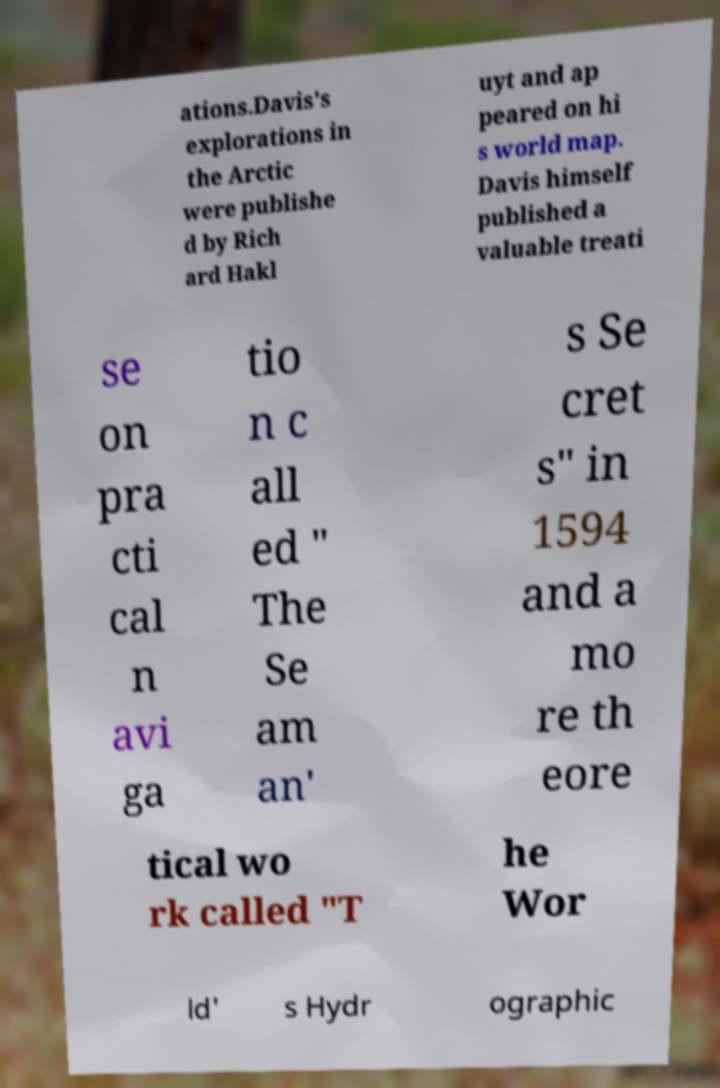For documentation purposes, I need the text within this image transcribed. Could you provide that? ations.Davis's explorations in the Arctic were publishe d by Rich ard Hakl uyt and ap peared on hi s world map. Davis himself published a valuable treati se on pra cti cal n avi ga tio n c all ed " The Se am an' s Se cret s" in 1594 and a mo re th eore tical wo rk called "T he Wor ld' s Hydr ographic 